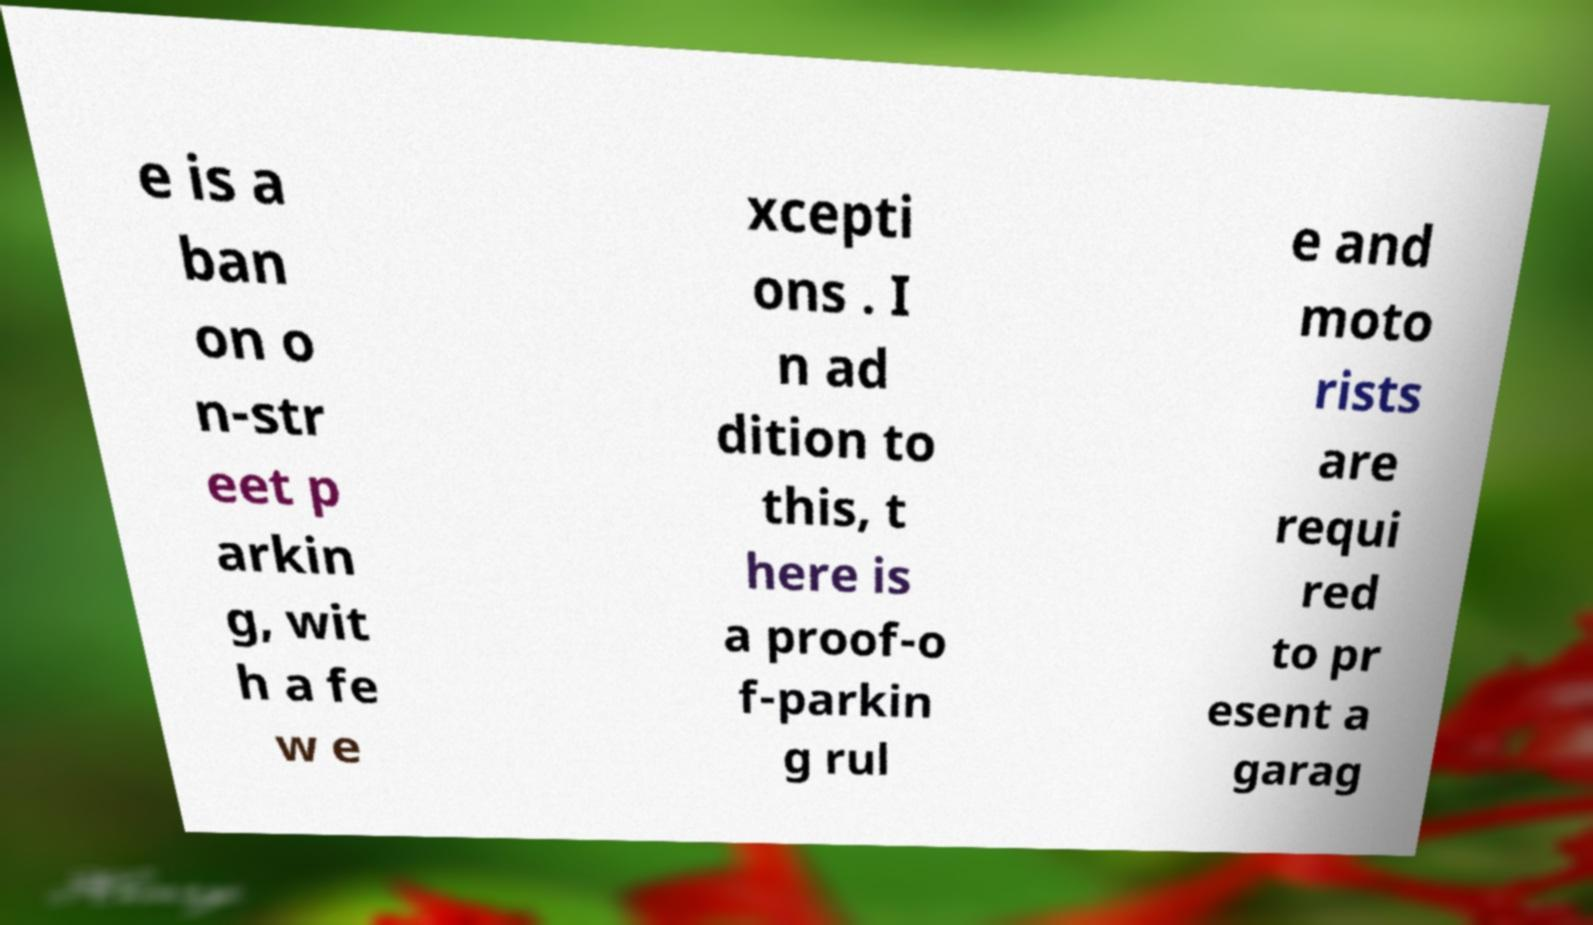Can you read and provide the text displayed in the image?This photo seems to have some interesting text. Can you extract and type it out for me? e is a ban on o n-str eet p arkin g, wit h a fe w e xcepti ons . I n ad dition to this, t here is a proof-o f-parkin g rul e and moto rists are requi red to pr esent a garag 